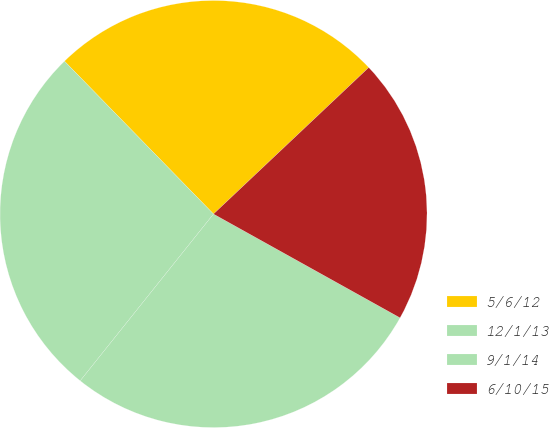<chart> <loc_0><loc_0><loc_500><loc_500><pie_chart><fcel>5/6/12<fcel>12/1/13<fcel>9/1/14<fcel>6/10/15<nl><fcel>25.26%<fcel>26.97%<fcel>27.65%<fcel>20.12%<nl></chart> 